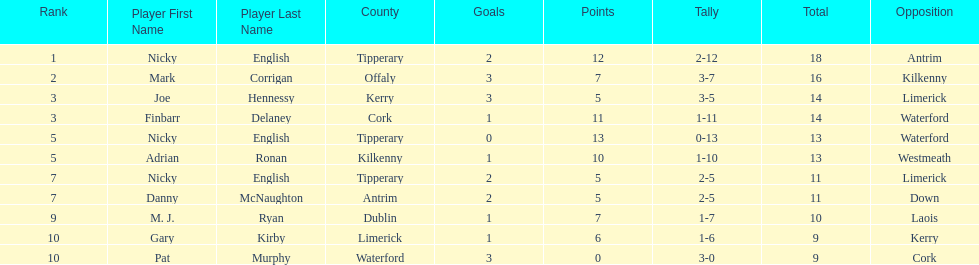What was the combined total of nicky english and mark corrigan? 34. 